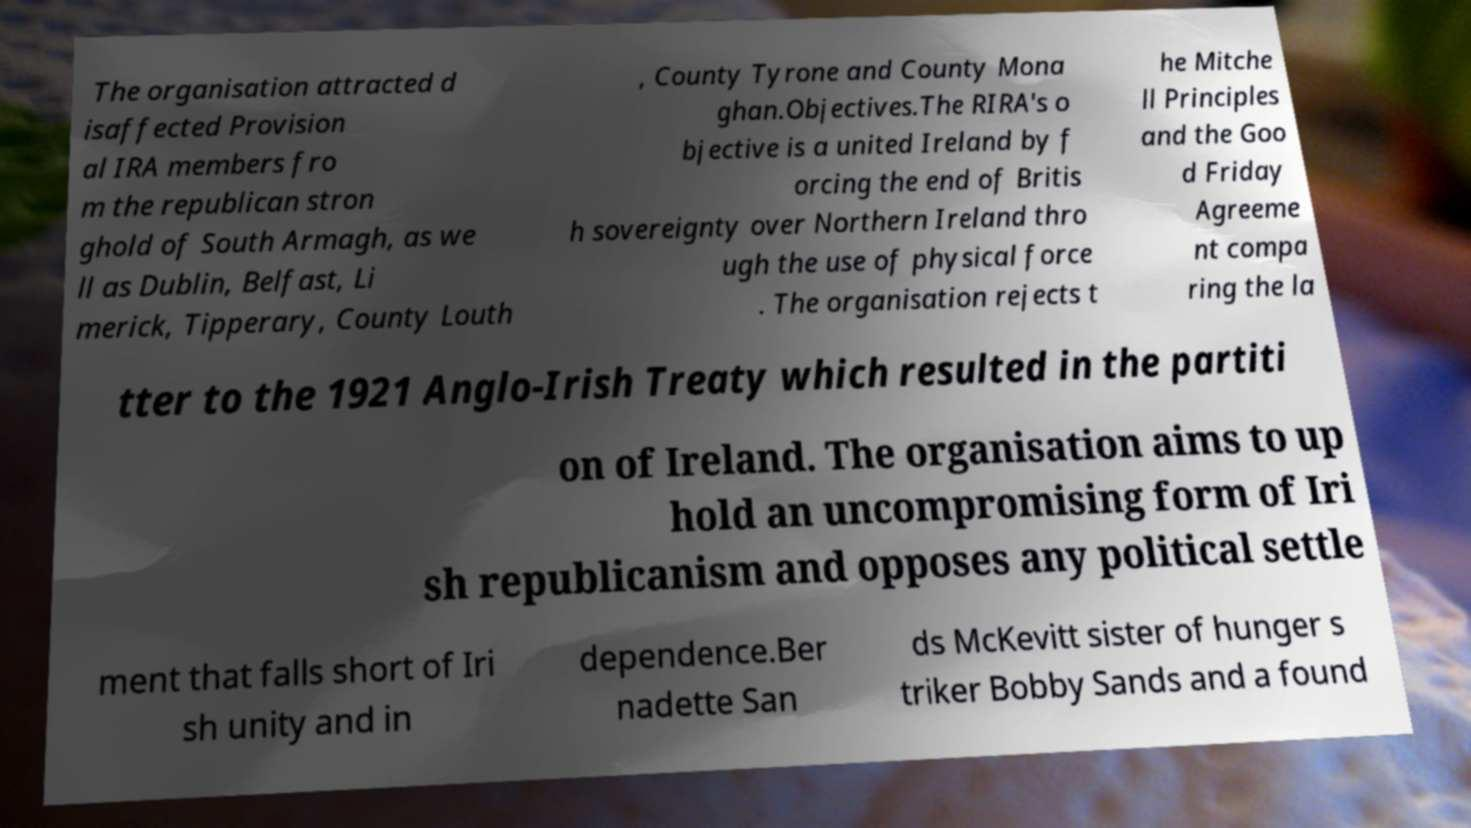Could you extract and type out the text from this image? The organisation attracted d isaffected Provision al IRA members fro m the republican stron ghold of South Armagh, as we ll as Dublin, Belfast, Li merick, Tipperary, County Louth , County Tyrone and County Mona ghan.Objectives.The RIRA's o bjective is a united Ireland by f orcing the end of Britis h sovereignty over Northern Ireland thro ugh the use of physical force . The organisation rejects t he Mitche ll Principles and the Goo d Friday Agreeme nt compa ring the la tter to the 1921 Anglo-Irish Treaty which resulted in the partiti on of Ireland. The organisation aims to up hold an uncompromising form of Iri sh republicanism and opposes any political settle ment that falls short of Iri sh unity and in dependence.Ber nadette San ds McKevitt sister of hunger s triker Bobby Sands and a found 